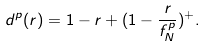Convert formula to latex. <formula><loc_0><loc_0><loc_500><loc_500>d ^ { p } ( r ) & = 1 - r + ( 1 - \frac { r } { f ^ { p } _ { N } } ) ^ { + } .</formula> 